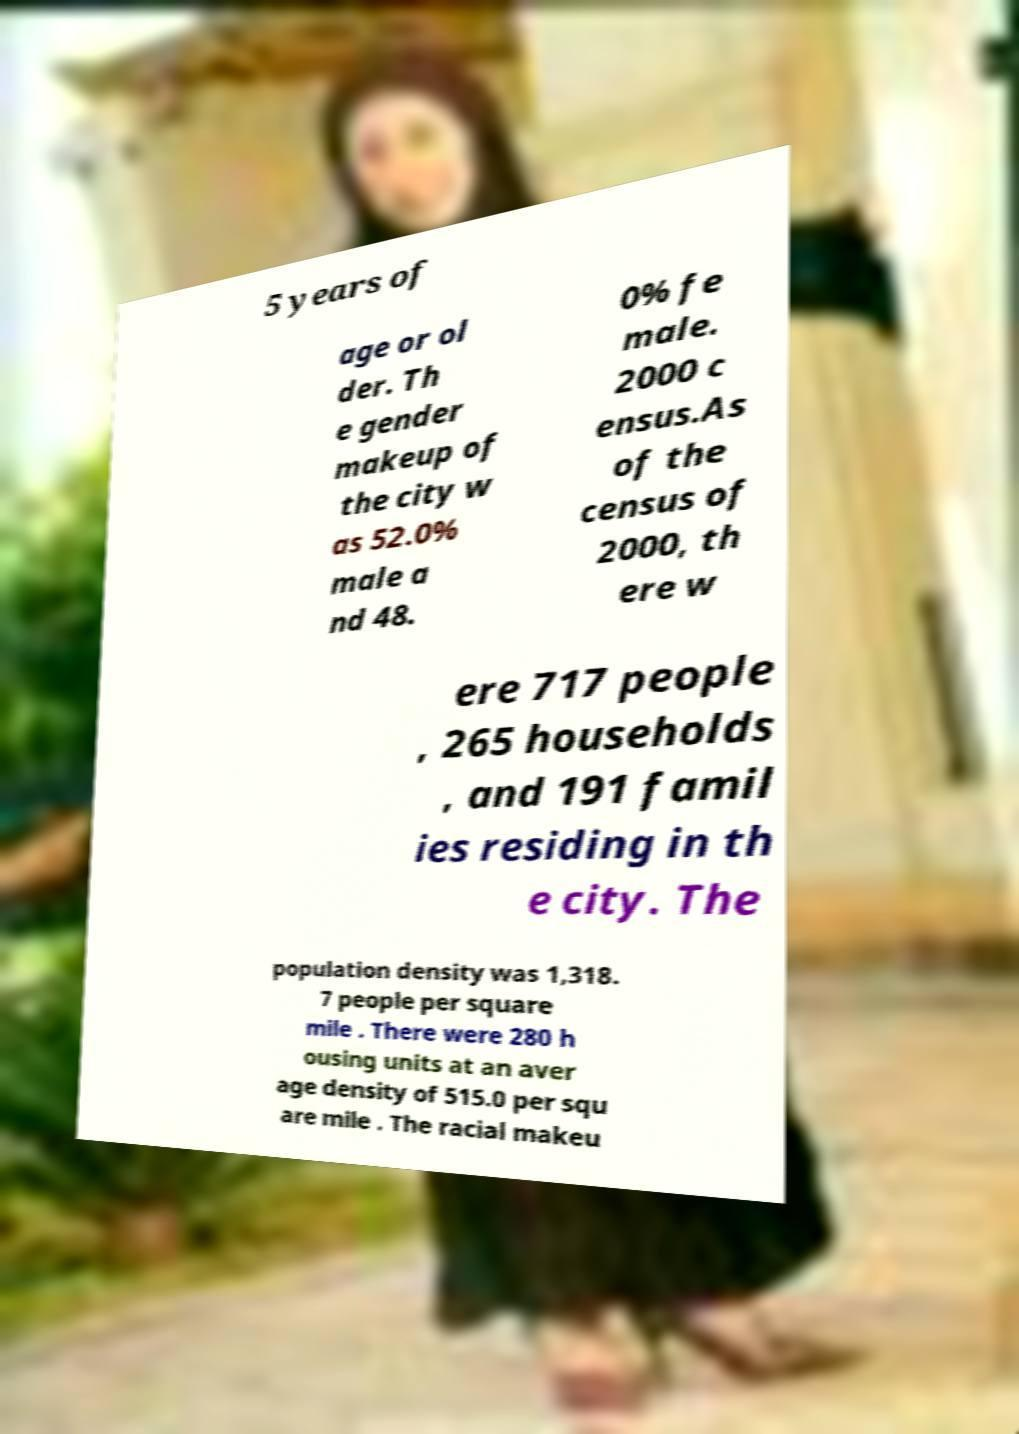Please read and relay the text visible in this image. What does it say? 5 years of age or ol der. Th e gender makeup of the city w as 52.0% male a nd 48. 0% fe male. 2000 c ensus.As of the census of 2000, th ere w ere 717 people , 265 households , and 191 famil ies residing in th e city. The population density was 1,318. 7 people per square mile . There were 280 h ousing units at an aver age density of 515.0 per squ are mile . The racial makeu 